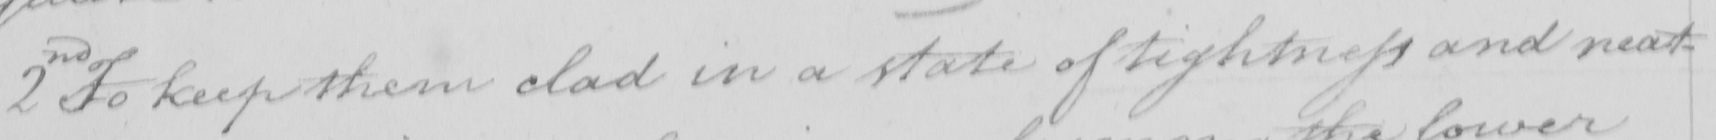What text is written in this handwritten line? 2nd To keep them clad in a state of tightness and neat- 